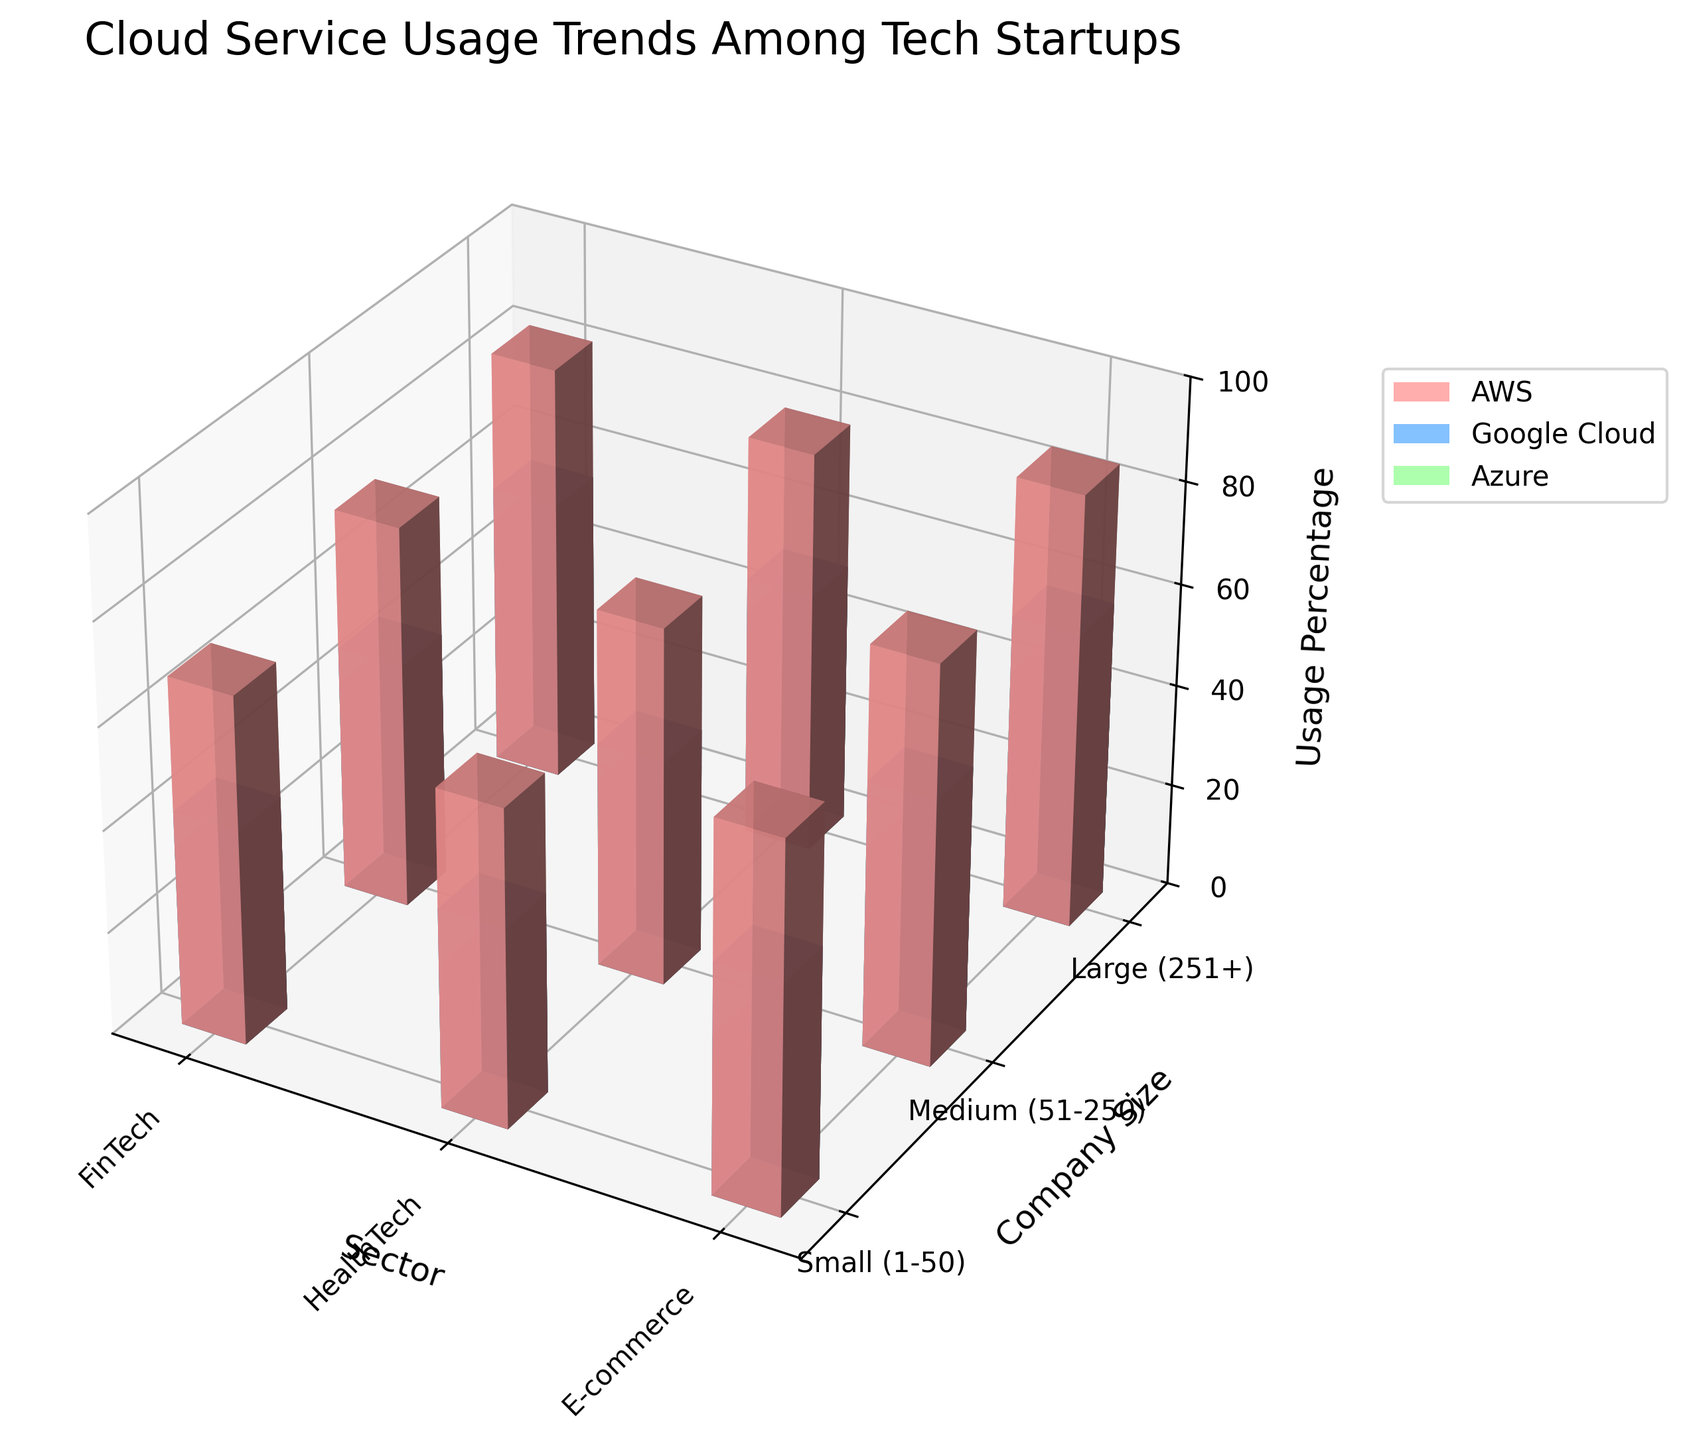What is the title of the figure? The title of the figure is typically displayed at the top of the plot. From the code, we know the title is "Cloud Service Usage Trends Among Tech Startups".
Answer: Cloud Service Usage Trends Among Tech Startups What are the axis labels? The axis labels describe the dimensions of the data in the figure. From the code, the X-axis is labeled 'Sector', the Y-axis is labeled 'Company Size', and the Z-axis is labeled 'Usage Percentage'.
Answer: Sector, Company Size, Usage Percentage Which sector has the highest AWS usage for small companies? To find this, look at the bars corresponding to 'AWS' across different sectors for small companies and identify the one with the highest bar. From the data, E-commerce has the highest AWS usage percentage of 72% for small companies.
Answer: E-commerce What is the usage percentage of Azure for medium HealthTech companies? Check the height of the bar representing Azure usage for medium-sized HealthTech companies. From the data, this value is 37%.
Answer: 37% Compare the usage of Google Cloud in large FinTech companies to large HealthTech companies. Which is higher? Look at the height of the bars for Google Cloud for large FinTech and HealthTech companies and compare them. From the data, the usage percentages are 55% and 51%, respectively, so FinTech has a higher usage.
Answer: FinTech What is the total cloud service usage percentage for AWS, Google Cloud, and Azure in large E-commerce companies? Sum the usage percentages for AWS, Google Cloud, and Azure in large E-commerce companies. From the data, these are 85%, 58%, and 47%. The total is 85 + 58 + 47 = 190%.
Answer: 190% Between AWS and Azure, which cloud service has more consistent usage across all sectors for medium-sized companies? Calculate the range of usage percentages for AWS and Azure across all sectors for medium companies, i.e., highest percentage minus lowest percentage. AWS: 78% (E-commerce) - 70% (HealthTech) = 8%; Azure: 41% (FinTech) - 37% (HealthTech) = 4%. Azure has a more consistent value.
Answer: Azure What is the average usage percentage of Google Cloud across all company sizes in the HealthTech sector? Find the values for Google Cloud usage in HealthTech across all sizes and compute the average. The values are 39%, 44%, and 51%, so average = (39 + 44 + 51) / 3 = 44.67%.
Answer: 44.67% Which cloud service has the least usage percentage for small FinTech companies? Compare the usage percentages for AWS, Google Cloud, and Azure in the small FinTech sector. Azure has the least usage with 35%.
Answer: Azure How does the usage of AWS in large companies compare to medium companies in the FinTech sector? Compare the heights of the AWS bars for large and medium companies in the FinTech sector. The usage percentages are 82% for large companies and 75% for medium companies. Large companies have higher usage.
Answer: Large companies have higher usage 